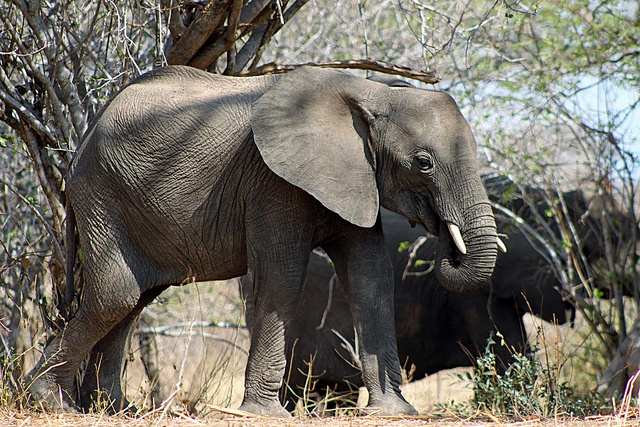Describe the objects in this image and their specific colors. I can see elephant in gray, black, and darkgray tones and elephant in gray, black, maroon, and darkgreen tones in this image. 